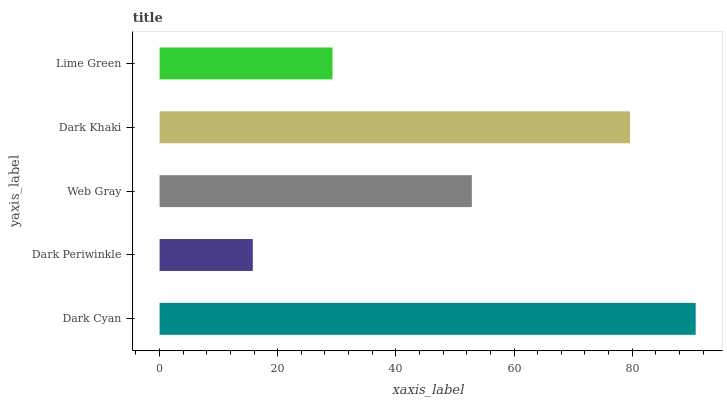Is Dark Periwinkle the minimum?
Answer yes or no. Yes. Is Dark Cyan the maximum?
Answer yes or no. Yes. Is Web Gray the minimum?
Answer yes or no. No. Is Web Gray the maximum?
Answer yes or no. No. Is Web Gray greater than Dark Periwinkle?
Answer yes or no. Yes. Is Dark Periwinkle less than Web Gray?
Answer yes or no. Yes. Is Dark Periwinkle greater than Web Gray?
Answer yes or no. No. Is Web Gray less than Dark Periwinkle?
Answer yes or no. No. Is Web Gray the high median?
Answer yes or no. Yes. Is Web Gray the low median?
Answer yes or no. Yes. Is Dark Periwinkle the high median?
Answer yes or no. No. Is Dark Khaki the low median?
Answer yes or no. No. 